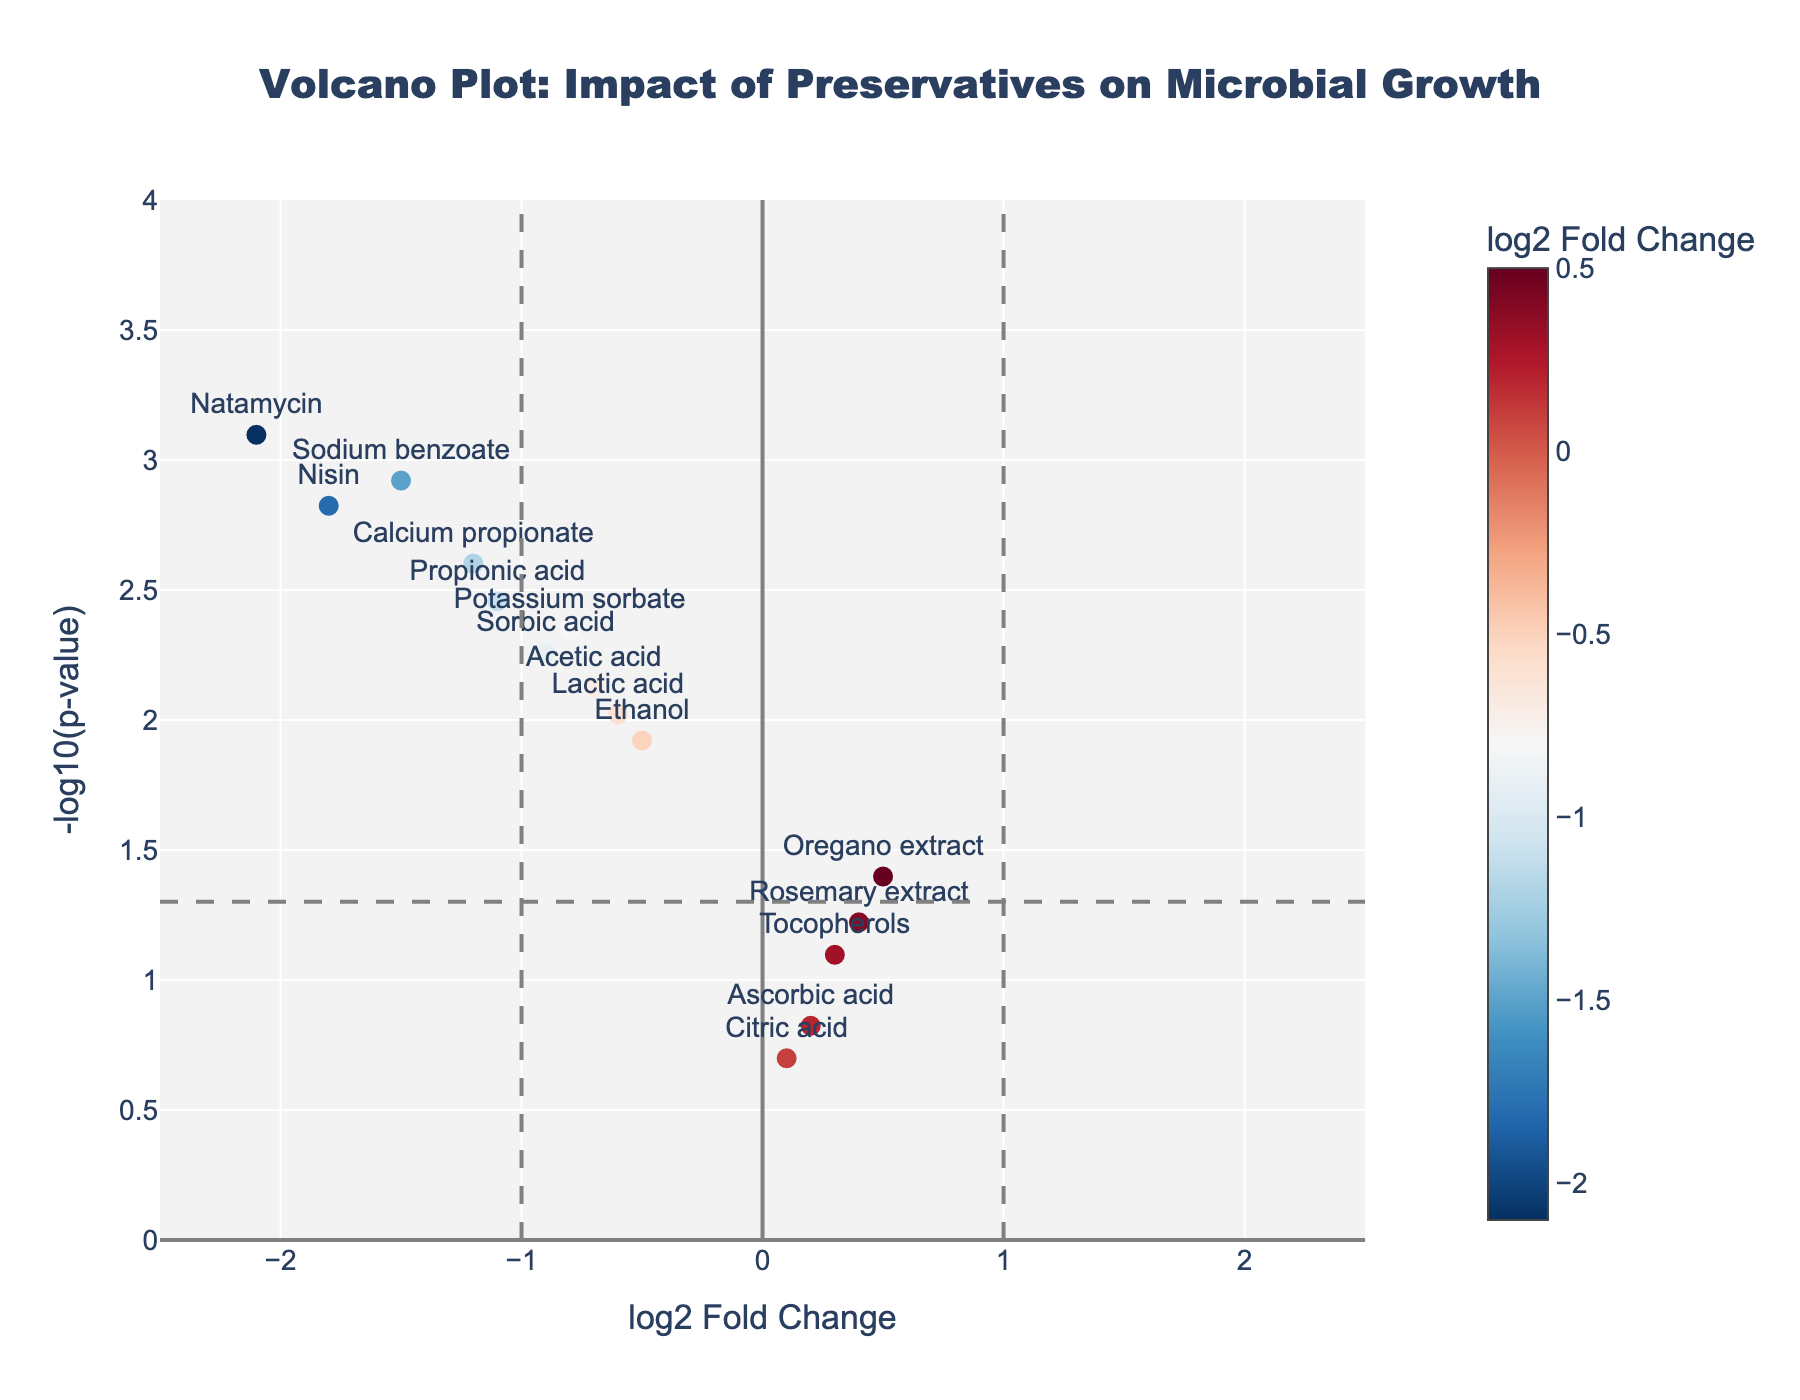What is the title of the plot? The title of the plot is found at the top center of the plot. It explains the overall purpose of the visualization.
Answer: Volcano Plot: Impact of Preservatives on Microbial Growth Which preservative has the smallest p-value? The p-value can be determined by looking at the y-axis value which has the highest -log10(p-value) indication. The preservative with the highest y-axis value is the one with the smallest p-value.
Answer: Natamycin How many preservatives show a negative log2 fold change? To answer this, count the number of data points that are positioned to the left of the vertical line at x=0.
Answer: 10 Which preservative appears to have the least significant impact on microbial growth based on its p-value? The least significant impact based on p-value can be determined by identifying the preservative with the smallest y-axis value, as this correlates to the highest p-value.
Answer: Citric acid Compare the log2 fold changes of Nisin and Sorbic acid. Which one has a more negative effect on microbial growth? To determine this, examine the positions of both preservatives along the x-axis and compare their log2 fold changes. The preservative further to the left has a more negative effect.
Answer: Nisin According to the plot, which preservative has the highest log2 fold change? The preservative with the highest log2 fold change is the one that is positioned furthest to the right on the x-axis.
Answer: Oregano extract How many preservatives have a p-value lower than 0.01? Look for the horizontal dashed line that correlates to -log10(0.01) on the y-axis and count the number of points above this line.
Answer: 8 Do any preservatives show a positive log2 fold change? If so, which ones? Examine the plot for any data points positioned to the right of the x-axis at 0. These represent preservatives with a positive log2 fold change.
Answer: Ascorbic acid, Citric acid, Tocopherols, Rosemary extract, Oregano extract Which preservative with a negative log2 fold change has the greatest impact on microbial growth? Identify the point furthest to the left (most negative log2 fold change) among the preservatives with negative fold changes. Check the corresponding label to determine the preservative.
Answer: Natamycin Are there any preservatives with a log2 fold change between -0.5 and 0.5 and a p-value greater than 0.05? List them. Focus on the range between -0.5 and 0.5 on the x-axis and identify the points that do not surpass the horizontal line representing p=0.05.
Answer: Ascorbic acid, Citric acid, Tocopherols, Rosemary extract, Oregano extract 